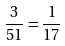Convert formula to latex. <formula><loc_0><loc_0><loc_500><loc_500>\frac { 3 } { 5 1 } = \frac { 1 } { 1 7 }</formula> 